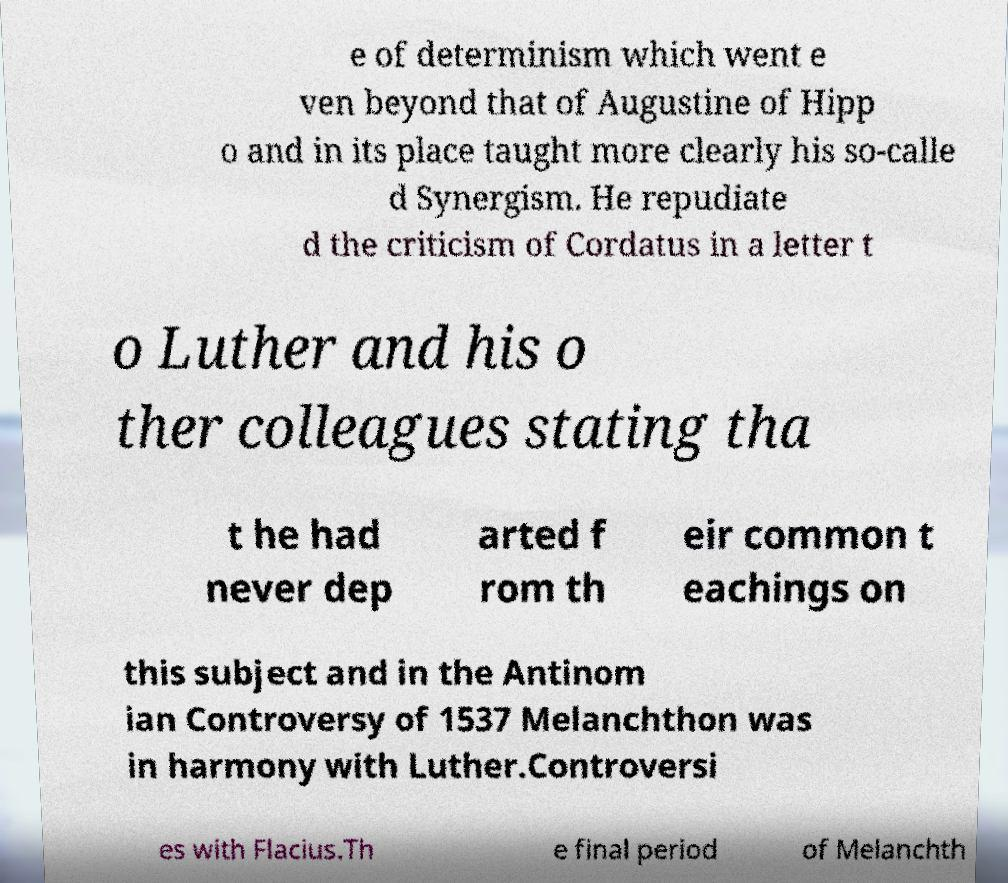Can you read and provide the text displayed in the image?This photo seems to have some interesting text. Can you extract and type it out for me? e of determinism which went e ven beyond that of Augustine of Hipp o and in its place taught more clearly his so-calle d Synergism. He repudiate d the criticism of Cordatus in a letter t o Luther and his o ther colleagues stating tha t he had never dep arted f rom th eir common t eachings on this subject and in the Antinom ian Controversy of 1537 Melanchthon was in harmony with Luther.Controversi es with Flacius.Th e final period of Melanchth 